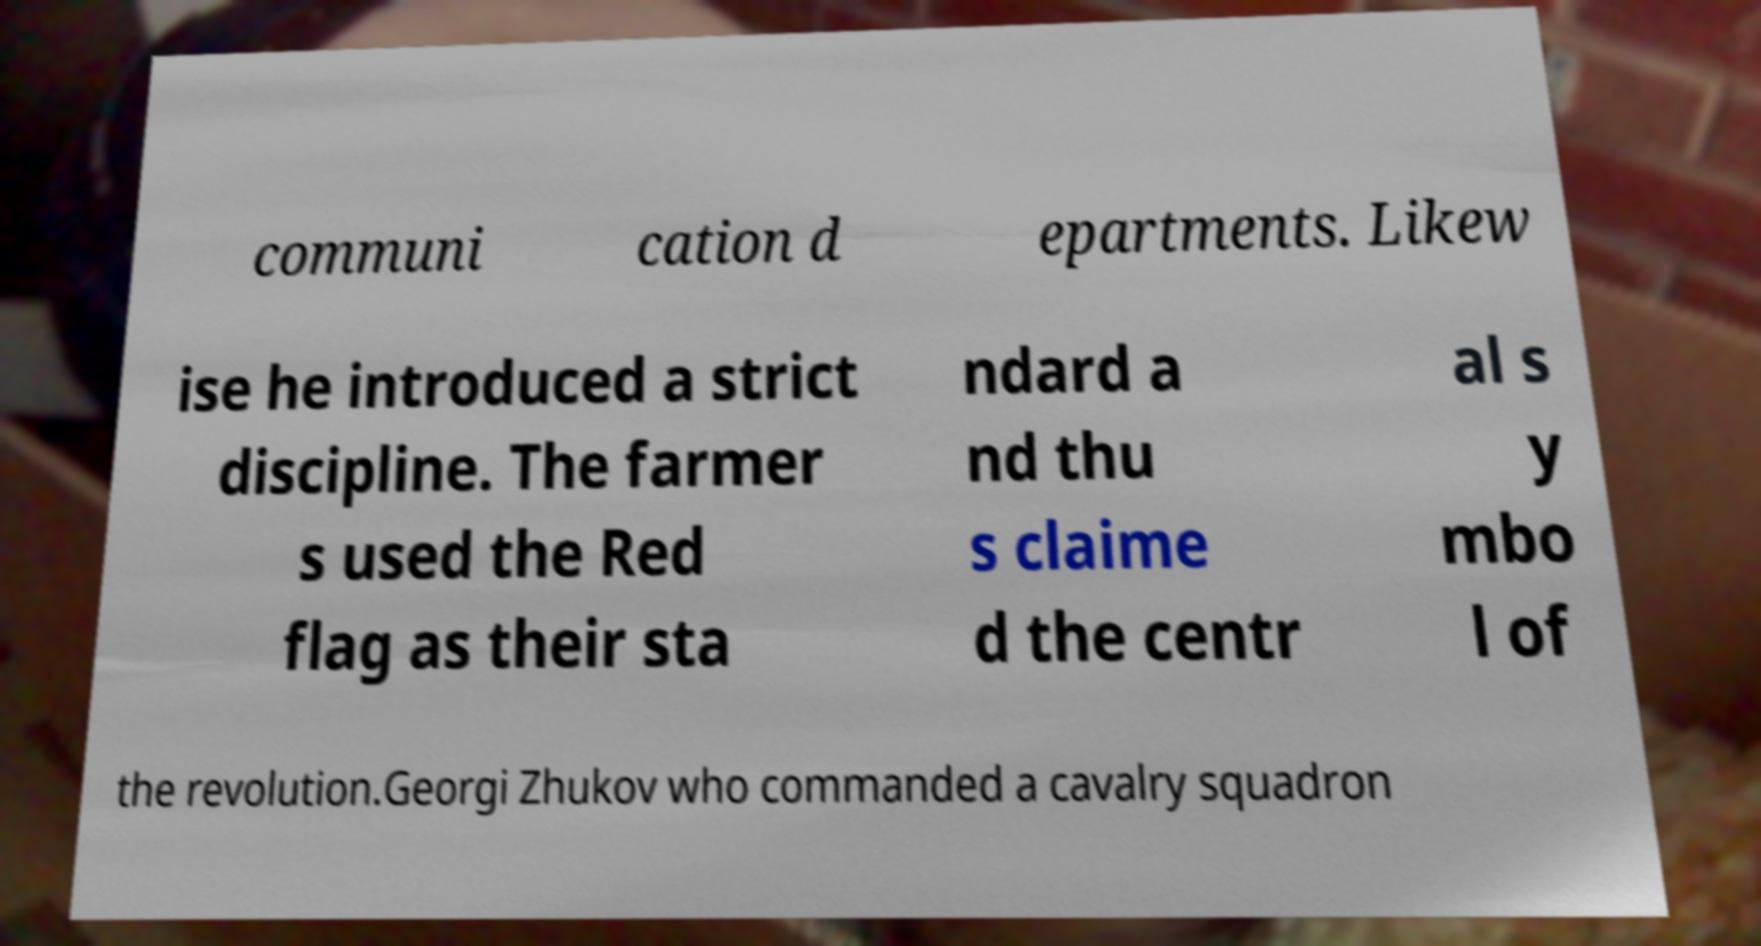Can you accurately transcribe the text from the provided image for me? communi cation d epartments. Likew ise he introduced a strict discipline. The farmer s used the Red flag as their sta ndard a nd thu s claime d the centr al s y mbo l of the revolution.Georgi Zhukov who commanded a cavalry squadron 